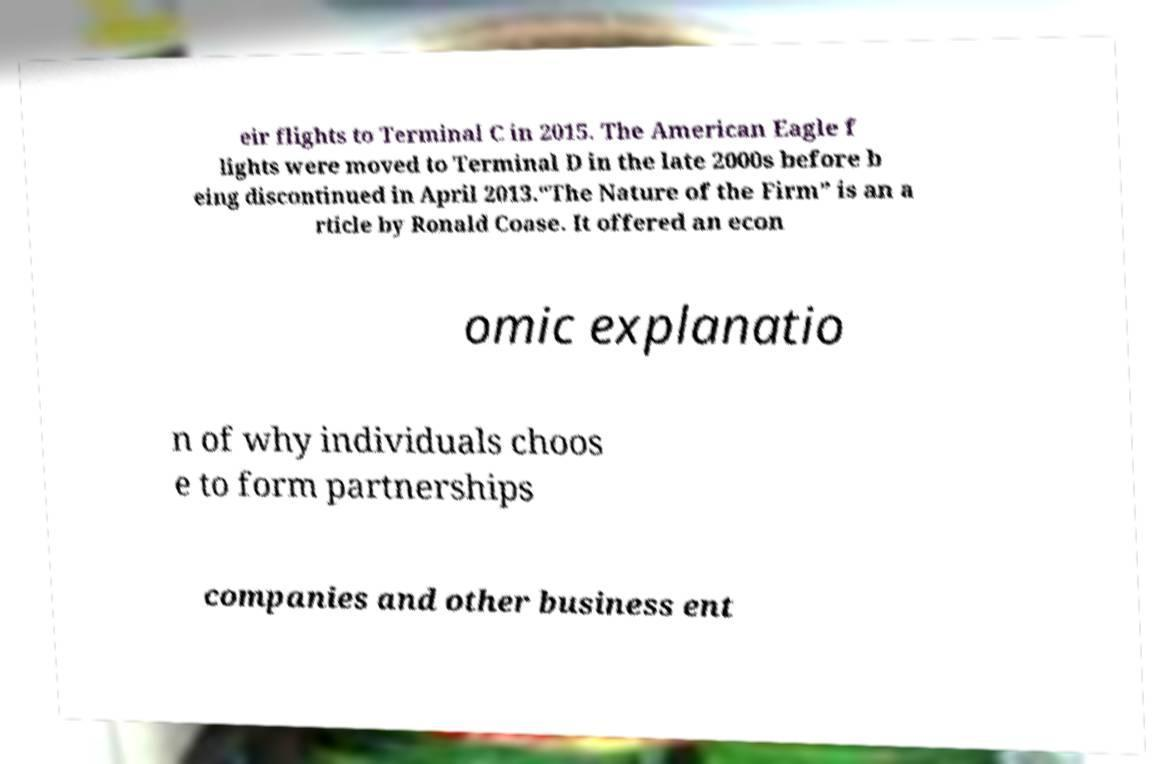Can you read and provide the text displayed in the image?This photo seems to have some interesting text. Can you extract and type it out for me? eir flights to Terminal C in 2015. The American Eagle f lights were moved to Terminal D in the late 2000s before b eing discontinued in April 2013.“The Nature of the Firm” is an a rticle by Ronald Coase. It offered an econ omic explanatio n of why individuals choos e to form partnerships companies and other business ent 